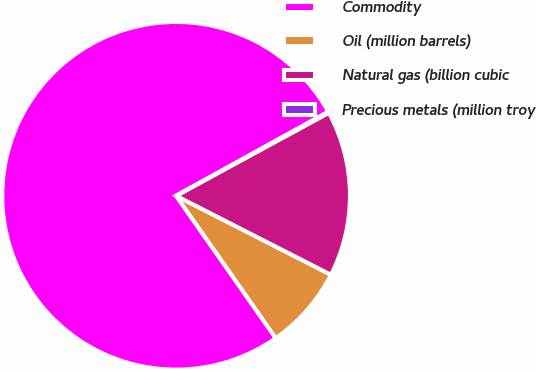Convert chart to OTSL. <chart><loc_0><loc_0><loc_500><loc_500><pie_chart><fcel>Commodity<fcel>Oil (million barrels)<fcel>Natural gas (billion cubic<fcel>Precious metals (million troy<nl><fcel>76.69%<fcel>7.77%<fcel>15.43%<fcel>0.11%<nl></chart> 